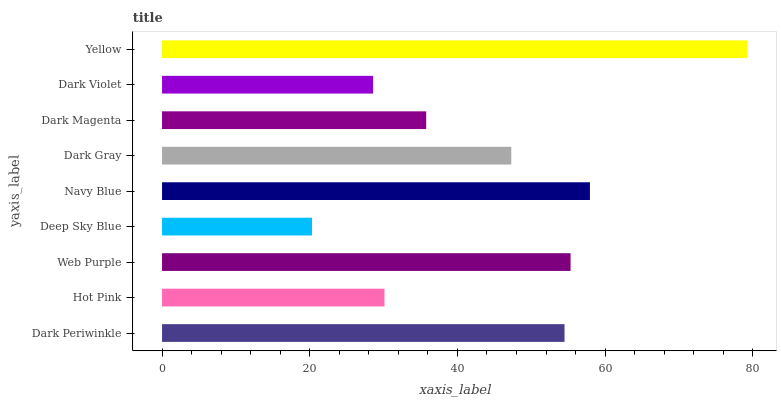Is Deep Sky Blue the minimum?
Answer yes or no. Yes. Is Yellow the maximum?
Answer yes or no. Yes. Is Hot Pink the minimum?
Answer yes or no. No. Is Hot Pink the maximum?
Answer yes or no. No. Is Dark Periwinkle greater than Hot Pink?
Answer yes or no. Yes. Is Hot Pink less than Dark Periwinkle?
Answer yes or no. Yes. Is Hot Pink greater than Dark Periwinkle?
Answer yes or no. No. Is Dark Periwinkle less than Hot Pink?
Answer yes or no. No. Is Dark Gray the high median?
Answer yes or no. Yes. Is Dark Gray the low median?
Answer yes or no. Yes. Is Dark Violet the high median?
Answer yes or no. No. Is Hot Pink the low median?
Answer yes or no. No. 